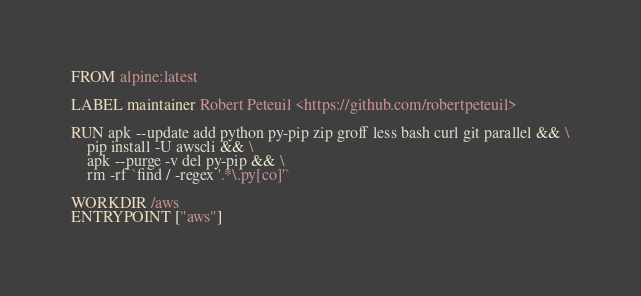Convert code to text. <code><loc_0><loc_0><loc_500><loc_500><_Dockerfile_>FROM alpine:latest

LABEL maintainer Robert Peteuil <https://github.com/robertpeteuil>

RUN apk --update add python py-pip zip groff less bash curl git parallel && \
    pip install -U awscli && \
    apk --purge -v del py-pip && \
    rm -rf `find / -regex '.*\.py[co]'`

WORKDIR /aws
ENTRYPOINT ["aws"]
</code> 